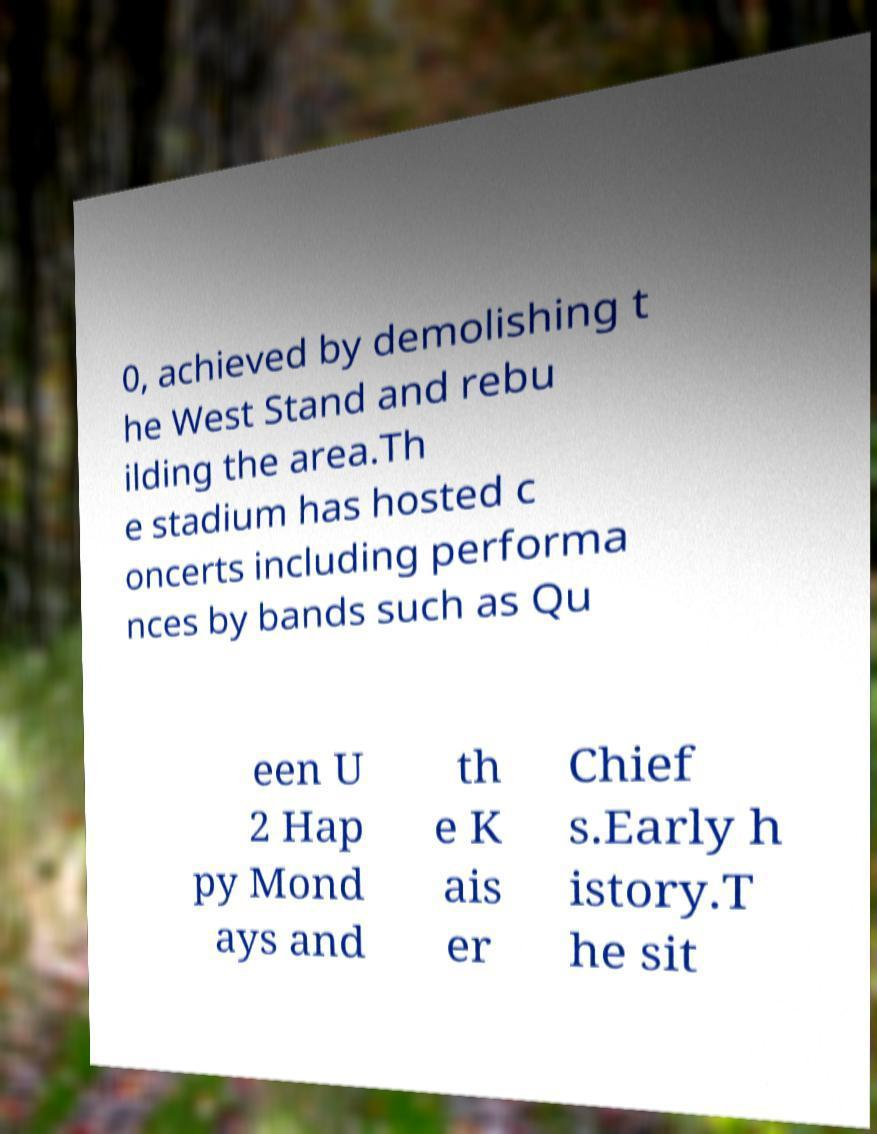There's text embedded in this image that I need extracted. Can you transcribe it verbatim? 0, achieved by demolishing t he West Stand and rebu ilding the area.Th e stadium has hosted c oncerts including performa nces by bands such as Qu een U 2 Hap py Mond ays and th e K ais er Chief s.Early h istory.T he sit 